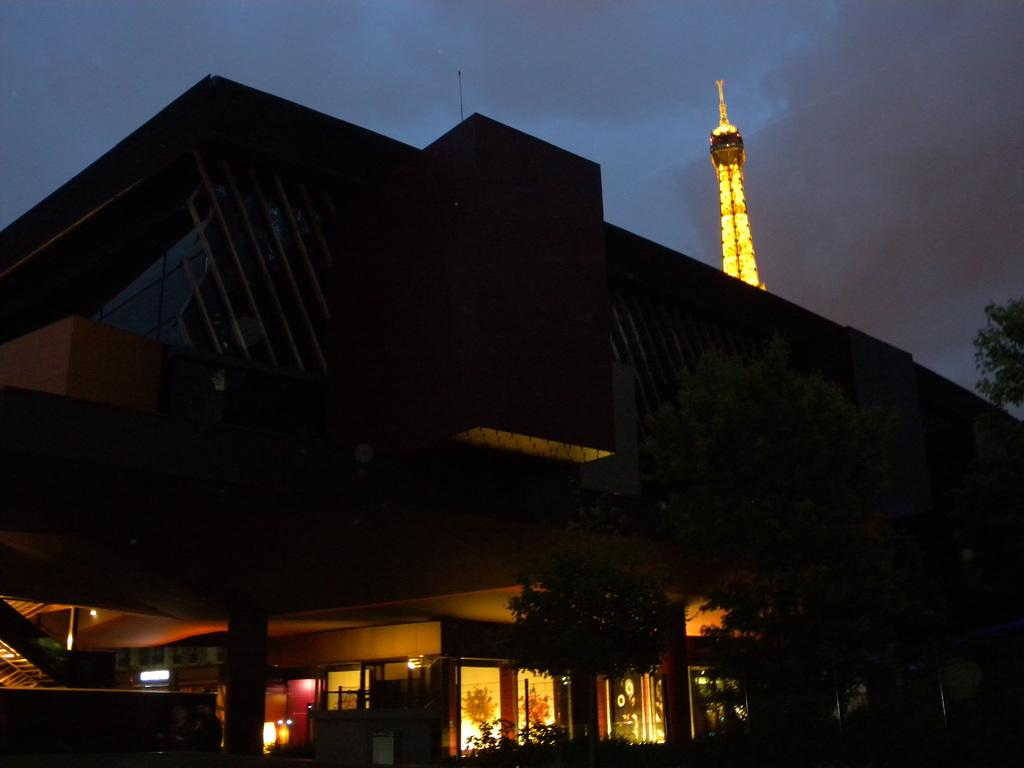What is the main structure in the image? There is a tower in the image. What other types of structures can be seen in the image? There are buildings in the image. What natural elements are present in the image? There are trees in the image. What type of artificial lighting is visible in the image? Electric lights are visible in the image. Are there any architectural features that allow for vertical movement in the image? Yes, there are staircases in the image. What is visible in the background of the image? The sky is visible in the image, and clouds are present in the sky. What type of sponge is being used for the print distribution in the image? There is no sponge or print distribution present in the image. 